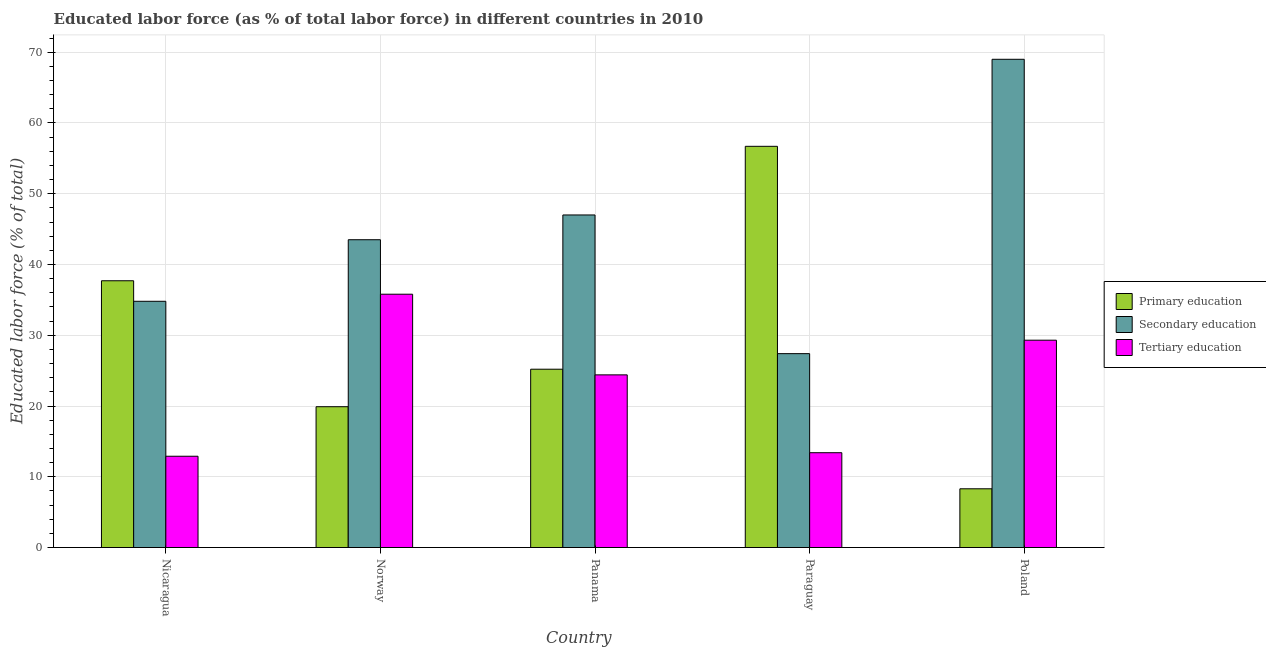How many groups of bars are there?
Offer a very short reply. 5. Are the number of bars per tick equal to the number of legend labels?
Provide a succinct answer. Yes. Are the number of bars on each tick of the X-axis equal?
Offer a terse response. Yes. What is the percentage of labor force who received secondary education in Norway?
Your answer should be compact. 43.5. Across all countries, what is the minimum percentage of labor force who received tertiary education?
Offer a terse response. 12.9. In which country was the percentage of labor force who received primary education maximum?
Your response must be concise. Paraguay. What is the total percentage of labor force who received secondary education in the graph?
Make the answer very short. 221.7. What is the difference between the percentage of labor force who received tertiary education in Norway and that in Paraguay?
Give a very brief answer. 22.4. What is the difference between the percentage of labor force who received primary education in Paraguay and the percentage of labor force who received secondary education in Poland?
Keep it short and to the point. -12.3. What is the average percentage of labor force who received tertiary education per country?
Provide a short and direct response. 23.16. What is the difference between the percentage of labor force who received secondary education and percentage of labor force who received tertiary education in Paraguay?
Offer a terse response. 14. What is the ratio of the percentage of labor force who received tertiary education in Norway to that in Paraguay?
Give a very brief answer. 2.67. Is the percentage of labor force who received primary education in Nicaragua less than that in Poland?
Provide a succinct answer. No. What is the difference between the highest and the lowest percentage of labor force who received primary education?
Provide a short and direct response. 48.4. In how many countries, is the percentage of labor force who received primary education greater than the average percentage of labor force who received primary education taken over all countries?
Your answer should be very brief. 2. Is the sum of the percentage of labor force who received primary education in Paraguay and Poland greater than the maximum percentage of labor force who received secondary education across all countries?
Ensure brevity in your answer.  No. What does the 2nd bar from the left in Paraguay represents?
Offer a terse response. Secondary education. What does the 2nd bar from the right in Poland represents?
Offer a terse response. Secondary education. Is it the case that in every country, the sum of the percentage of labor force who received primary education and percentage of labor force who received secondary education is greater than the percentage of labor force who received tertiary education?
Offer a terse response. Yes. Are all the bars in the graph horizontal?
Provide a succinct answer. No. How many countries are there in the graph?
Make the answer very short. 5. What is the difference between two consecutive major ticks on the Y-axis?
Your response must be concise. 10. Where does the legend appear in the graph?
Ensure brevity in your answer.  Center right. How many legend labels are there?
Offer a very short reply. 3. What is the title of the graph?
Make the answer very short. Educated labor force (as % of total labor force) in different countries in 2010. What is the label or title of the X-axis?
Offer a very short reply. Country. What is the label or title of the Y-axis?
Your response must be concise. Educated labor force (% of total). What is the Educated labor force (% of total) of Primary education in Nicaragua?
Keep it short and to the point. 37.7. What is the Educated labor force (% of total) in Secondary education in Nicaragua?
Keep it short and to the point. 34.8. What is the Educated labor force (% of total) in Tertiary education in Nicaragua?
Give a very brief answer. 12.9. What is the Educated labor force (% of total) of Primary education in Norway?
Give a very brief answer. 19.9. What is the Educated labor force (% of total) of Secondary education in Norway?
Your response must be concise. 43.5. What is the Educated labor force (% of total) of Tertiary education in Norway?
Your answer should be compact. 35.8. What is the Educated labor force (% of total) of Primary education in Panama?
Ensure brevity in your answer.  25.2. What is the Educated labor force (% of total) in Secondary education in Panama?
Keep it short and to the point. 47. What is the Educated labor force (% of total) in Tertiary education in Panama?
Provide a short and direct response. 24.4. What is the Educated labor force (% of total) of Primary education in Paraguay?
Your answer should be compact. 56.7. What is the Educated labor force (% of total) in Secondary education in Paraguay?
Your answer should be very brief. 27.4. What is the Educated labor force (% of total) of Tertiary education in Paraguay?
Provide a succinct answer. 13.4. What is the Educated labor force (% of total) in Primary education in Poland?
Your answer should be very brief. 8.3. What is the Educated labor force (% of total) of Secondary education in Poland?
Provide a succinct answer. 69. What is the Educated labor force (% of total) in Tertiary education in Poland?
Make the answer very short. 29.3. Across all countries, what is the maximum Educated labor force (% of total) in Primary education?
Keep it short and to the point. 56.7. Across all countries, what is the maximum Educated labor force (% of total) in Secondary education?
Offer a very short reply. 69. Across all countries, what is the maximum Educated labor force (% of total) of Tertiary education?
Keep it short and to the point. 35.8. Across all countries, what is the minimum Educated labor force (% of total) in Primary education?
Provide a short and direct response. 8.3. Across all countries, what is the minimum Educated labor force (% of total) of Secondary education?
Make the answer very short. 27.4. Across all countries, what is the minimum Educated labor force (% of total) of Tertiary education?
Ensure brevity in your answer.  12.9. What is the total Educated labor force (% of total) of Primary education in the graph?
Provide a succinct answer. 147.8. What is the total Educated labor force (% of total) of Secondary education in the graph?
Your answer should be very brief. 221.7. What is the total Educated labor force (% of total) of Tertiary education in the graph?
Your response must be concise. 115.8. What is the difference between the Educated labor force (% of total) of Primary education in Nicaragua and that in Norway?
Keep it short and to the point. 17.8. What is the difference between the Educated labor force (% of total) in Secondary education in Nicaragua and that in Norway?
Offer a terse response. -8.7. What is the difference between the Educated labor force (% of total) of Tertiary education in Nicaragua and that in Norway?
Give a very brief answer. -22.9. What is the difference between the Educated labor force (% of total) in Primary education in Nicaragua and that in Panama?
Your answer should be compact. 12.5. What is the difference between the Educated labor force (% of total) of Tertiary education in Nicaragua and that in Panama?
Offer a terse response. -11.5. What is the difference between the Educated labor force (% of total) of Tertiary education in Nicaragua and that in Paraguay?
Provide a succinct answer. -0.5. What is the difference between the Educated labor force (% of total) in Primary education in Nicaragua and that in Poland?
Offer a terse response. 29.4. What is the difference between the Educated labor force (% of total) in Secondary education in Nicaragua and that in Poland?
Provide a short and direct response. -34.2. What is the difference between the Educated labor force (% of total) of Tertiary education in Nicaragua and that in Poland?
Provide a short and direct response. -16.4. What is the difference between the Educated labor force (% of total) of Tertiary education in Norway and that in Panama?
Make the answer very short. 11.4. What is the difference between the Educated labor force (% of total) of Primary education in Norway and that in Paraguay?
Your answer should be compact. -36.8. What is the difference between the Educated labor force (% of total) in Secondary education in Norway and that in Paraguay?
Ensure brevity in your answer.  16.1. What is the difference between the Educated labor force (% of total) in Tertiary education in Norway and that in Paraguay?
Offer a very short reply. 22.4. What is the difference between the Educated labor force (% of total) in Primary education in Norway and that in Poland?
Keep it short and to the point. 11.6. What is the difference between the Educated labor force (% of total) of Secondary education in Norway and that in Poland?
Your answer should be compact. -25.5. What is the difference between the Educated labor force (% of total) in Tertiary education in Norway and that in Poland?
Make the answer very short. 6.5. What is the difference between the Educated labor force (% of total) in Primary education in Panama and that in Paraguay?
Offer a terse response. -31.5. What is the difference between the Educated labor force (% of total) of Secondary education in Panama and that in Paraguay?
Ensure brevity in your answer.  19.6. What is the difference between the Educated labor force (% of total) of Tertiary education in Panama and that in Paraguay?
Offer a very short reply. 11. What is the difference between the Educated labor force (% of total) in Tertiary education in Panama and that in Poland?
Make the answer very short. -4.9. What is the difference between the Educated labor force (% of total) of Primary education in Paraguay and that in Poland?
Offer a terse response. 48.4. What is the difference between the Educated labor force (% of total) of Secondary education in Paraguay and that in Poland?
Your response must be concise. -41.6. What is the difference between the Educated labor force (% of total) of Tertiary education in Paraguay and that in Poland?
Give a very brief answer. -15.9. What is the difference between the Educated labor force (% of total) in Primary education in Nicaragua and the Educated labor force (% of total) in Tertiary education in Norway?
Keep it short and to the point. 1.9. What is the difference between the Educated labor force (% of total) in Secondary education in Nicaragua and the Educated labor force (% of total) in Tertiary education in Norway?
Make the answer very short. -1. What is the difference between the Educated labor force (% of total) of Primary education in Nicaragua and the Educated labor force (% of total) of Secondary education in Panama?
Give a very brief answer. -9.3. What is the difference between the Educated labor force (% of total) of Primary education in Nicaragua and the Educated labor force (% of total) of Tertiary education in Panama?
Offer a very short reply. 13.3. What is the difference between the Educated labor force (% of total) in Secondary education in Nicaragua and the Educated labor force (% of total) in Tertiary education in Panama?
Provide a succinct answer. 10.4. What is the difference between the Educated labor force (% of total) in Primary education in Nicaragua and the Educated labor force (% of total) in Secondary education in Paraguay?
Your response must be concise. 10.3. What is the difference between the Educated labor force (% of total) in Primary education in Nicaragua and the Educated labor force (% of total) in Tertiary education in Paraguay?
Provide a short and direct response. 24.3. What is the difference between the Educated labor force (% of total) in Secondary education in Nicaragua and the Educated labor force (% of total) in Tertiary education in Paraguay?
Offer a very short reply. 21.4. What is the difference between the Educated labor force (% of total) in Primary education in Nicaragua and the Educated labor force (% of total) in Secondary education in Poland?
Provide a short and direct response. -31.3. What is the difference between the Educated labor force (% of total) of Primary education in Nicaragua and the Educated labor force (% of total) of Tertiary education in Poland?
Make the answer very short. 8.4. What is the difference between the Educated labor force (% of total) of Primary education in Norway and the Educated labor force (% of total) of Secondary education in Panama?
Offer a terse response. -27.1. What is the difference between the Educated labor force (% of total) in Primary education in Norway and the Educated labor force (% of total) in Tertiary education in Panama?
Offer a terse response. -4.5. What is the difference between the Educated labor force (% of total) of Secondary education in Norway and the Educated labor force (% of total) of Tertiary education in Panama?
Your answer should be very brief. 19.1. What is the difference between the Educated labor force (% of total) in Primary education in Norway and the Educated labor force (% of total) in Secondary education in Paraguay?
Ensure brevity in your answer.  -7.5. What is the difference between the Educated labor force (% of total) in Secondary education in Norway and the Educated labor force (% of total) in Tertiary education in Paraguay?
Ensure brevity in your answer.  30.1. What is the difference between the Educated labor force (% of total) in Primary education in Norway and the Educated labor force (% of total) in Secondary education in Poland?
Keep it short and to the point. -49.1. What is the difference between the Educated labor force (% of total) of Secondary education in Norway and the Educated labor force (% of total) of Tertiary education in Poland?
Provide a short and direct response. 14.2. What is the difference between the Educated labor force (% of total) in Primary education in Panama and the Educated labor force (% of total) in Tertiary education in Paraguay?
Provide a short and direct response. 11.8. What is the difference between the Educated labor force (% of total) in Secondary education in Panama and the Educated labor force (% of total) in Tertiary education in Paraguay?
Provide a succinct answer. 33.6. What is the difference between the Educated labor force (% of total) of Primary education in Panama and the Educated labor force (% of total) of Secondary education in Poland?
Provide a succinct answer. -43.8. What is the difference between the Educated labor force (% of total) of Primary education in Paraguay and the Educated labor force (% of total) of Secondary education in Poland?
Ensure brevity in your answer.  -12.3. What is the difference between the Educated labor force (% of total) in Primary education in Paraguay and the Educated labor force (% of total) in Tertiary education in Poland?
Make the answer very short. 27.4. What is the average Educated labor force (% of total) in Primary education per country?
Make the answer very short. 29.56. What is the average Educated labor force (% of total) of Secondary education per country?
Make the answer very short. 44.34. What is the average Educated labor force (% of total) in Tertiary education per country?
Keep it short and to the point. 23.16. What is the difference between the Educated labor force (% of total) in Primary education and Educated labor force (% of total) in Secondary education in Nicaragua?
Give a very brief answer. 2.9. What is the difference between the Educated labor force (% of total) in Primary education and Educated labor force (% of total) in Tertiary education in Nicaragua?
Your answer should be very brief. 24.8. What is the difference between the Educated labor force (% of total) in Secondary education and Educated labor force (% of total) in Tertiary education in Nicaragua?
Give a very brief answer. 21.9. What is the difference between the Educated labor force (% of total) in Primary education and Educated labor force (% of total) in Secondary education in Norway?
Your answer should be very brief. -23.6. What is the difference between the Educated labor force (% of total) of Primary education and Educated labor force (% of total) of Tertiary education in Norway?
Keep it short and to the point. -15.9. What is the difference between the Educated labor force (% of total) of Secondary education and Educated labor force (% of total) of Tertiary education in Norway?
Your response must be concise. 7.7. What is the difference between the Educated labor force (% of total) of Primary education and Educated labor force (% of total) of Secondary education in Panama?
Offer a terse response. -21.8. What is the difference between the Educated labor force (% of total) in Primary education and Educated labor force (% of total) in Tertiary education in Panama?
Ensure brevity in your answer.  0.8. What is the difference between the Educated labor force (% of total) in Secondary education and Educated labor force (% of total) in Tertiary education in Panama?
Keep it short and to the point. 22.6. What is the difference between the Educated labor force (% of total) in Primary education and Educated labor force (% of total) in Secondary education in Paraguay?
Offer a very short reply. 29.3. What is the difference between the Educated labor force (% of total) in Primary education and Educated labor force (% of total) in Tertiary education in Paraguay?
Provide a short and direct response. 43.3. What is the difference between the Educated labor force (% of total) of Secondary education and Educated labor force (% of total) of Tertiary education in Paraguay?
Your answer should be very brief. 14. What is the difference between the Educated labor force (% of total) of Primary education and Educated labor force (% of total) of Secondary education in Poland?
Your response must be concise. -60.7. What is the difference between the Educated labor force (% of total) in Primary education and Educated labor force (% of total) in Tertiary education in Poland?
Keep it short and to the point. -21. What is the difference between the Educated labor force (% of total) in Secondary education and Educated labor force (% of total) in Tertiary education in Poland?
Your answer should be very brief. 39.7. What is the ratio of the Educated labor force (% of total) in Primary education in Nicaragua to that in Norway?
Your answer should be compact. 1.89. What is the ratio of the Educated labor force (% of total) of Secondary education in Nicaragua to that in Norway?
Offer a very short reply. 0.8. What is the ratio of the Educated labor force (% of total) in Tertiary education in Nicaragua to that in Norway?
Keep it short and to the point. 0.36. What is the ratio of the Educated labor force (% of total) in Primary education in Nicaragua to that in Panama?
Offer a very short reply. 1.5. What is the ratio of the Educated labor force (% of total) of Secondary education in Nicaragua to that in Panama?
Your answer should be very brief. 0.74. What is the ratio of the Educated labor force (% of total) in Tertiary education in Nicaragua to that in Panama?
Provide a short and direct response. 0.53. What is the ratio of the Educated labor force (% of total) of Primary education in Nicaragua to that in Paraguay?
Make the answer very short. 0.66. What is the ratio of the Educated labor force (% of total) in Secondary education in Nicaragua to that in Paraguay?
Your answer should be compact. 1.27. What is the ratio of the Educated labor force (% of total) in Tertiary education in Nicaragua to that in Paraguay?
Make the answer very short. 0.96. What is the ratio of the Educated labor force (% of total) of Primary education in Nicaragua to that in Poland?
Give a very brief answer. 4.54. What is the ratio of the Educated labor force (% of total) in Secondary education in Nicaragua to that in Poland?
Keep it short and to the point. 0.5. What is the ratio of the Educated labor force (% of total) of Tertiary education in Nicaragua to that in Poland?
Keep it short and to the point. 0.44. What is the ratio of the Educated labor force (% of total) of Primary education in Norway to that in Panama?
Your response must be concise. 0.79. What is the ratio of the Educated labor force (% of total) of Secondary education in Norway to that in Panama?
Provide a succinct answer. 0.93. What is the ratio of the Educated labor force (% of total) in Tertiary education in Norway to that in Panama?
Provide a succinct answer. 1.47. What is the ratio of the Educated labor force (% of total) in Primary education in Norway to that in Paraguay?
Give a very brief answer. 0.35. What is the ratio of the Educated labor force (% of total) of Secondary education in Norway to that in Paraguay?
Offer a terse response. 1.59. What is the ratio of the Educated labor force (% of total) in Tertiary education in Norway to that in Paraguay?
Your answer should be very brief. 2.67. What is the ratio of the Educated labor force (% of total) in Primary education in Norway to that in Poland?
Ensure brevity in your answer.  2.4. What is the ratio of the Educated labor force (% of total) in Secondary education in Norway to that in Poland?
Make the answer very short. 0.63. What is the ratio of the Educated labor force (% of total) of Tertiary education in Norway to that in Poland?
Give a very brief answer. 1.22. What is the ratio of the Educated labor force (% of total) of Primary education in Panama to that in Paraguay?
Provide a succinct answer. 0.44. What is the ratio of the Educated labor force (% of total) of Secondary education in Panama to that in Paraguay?
Provide a succinct answer. 1.72. What is the ratio of the Educated labor force (% of total) of Tertiary education in Panama to that in Paraguay?
Your response must be concise. 1.82. What is the ratio of the Educated labor force (% of total) of Primary education in Panama to that in Poland?
Provide a succinct answer. 3.04. What is the ratio of the Educated labor force (% of total) of Secondary education in Panama to that in Poland?
Make the answer very short. 0.68. What is the ratio of the Educated labor force (% of total) of Tertiary education in Panama to that in Poland?
Your answer should be compact. 0.83. What is the ratio of the Educated labor force (% of total) of Primary education in Paraguay to that in Poland?
Offer a terse response. 6.83. What is the ratio of the Educated labor force (% of total) in Secondary education in Paraguay to that in Poland?
Offer a terse response. 0.4. What is the ratio of the Educated labor force (% of total) of Tertiary education in Paraguay to that in Poland?
Ensure brevity in your answer.  0.46. What is the difference between the highest and the lowest Educated labor force (% of total) in Primary education?
Make the answer very short. 48.4. What is the difference between the highest and the lowest Educated labor force (% of total) of Secondary education?
Offer a very short reply. 41.6. What is the difference between the highest and the lowest Educated labor force (% of total) of Tertiary education?
Offer a terse response. 22.9. 